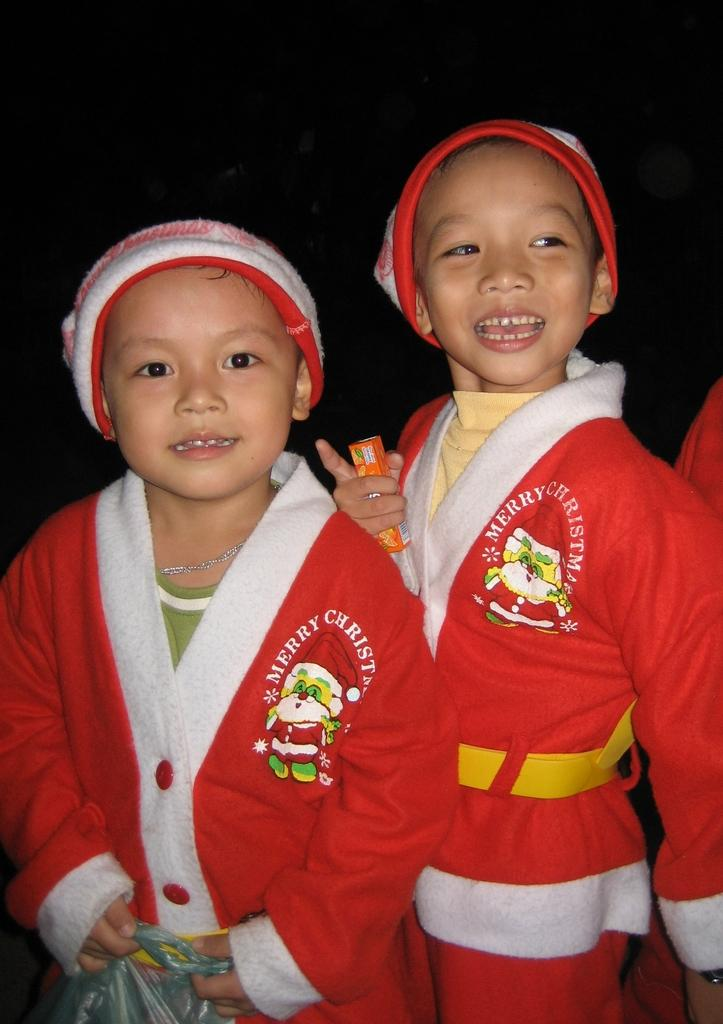<image>
Offer a succinct explanation of the picture presented. two little kids wear santa outfits that say Merry Christmas 